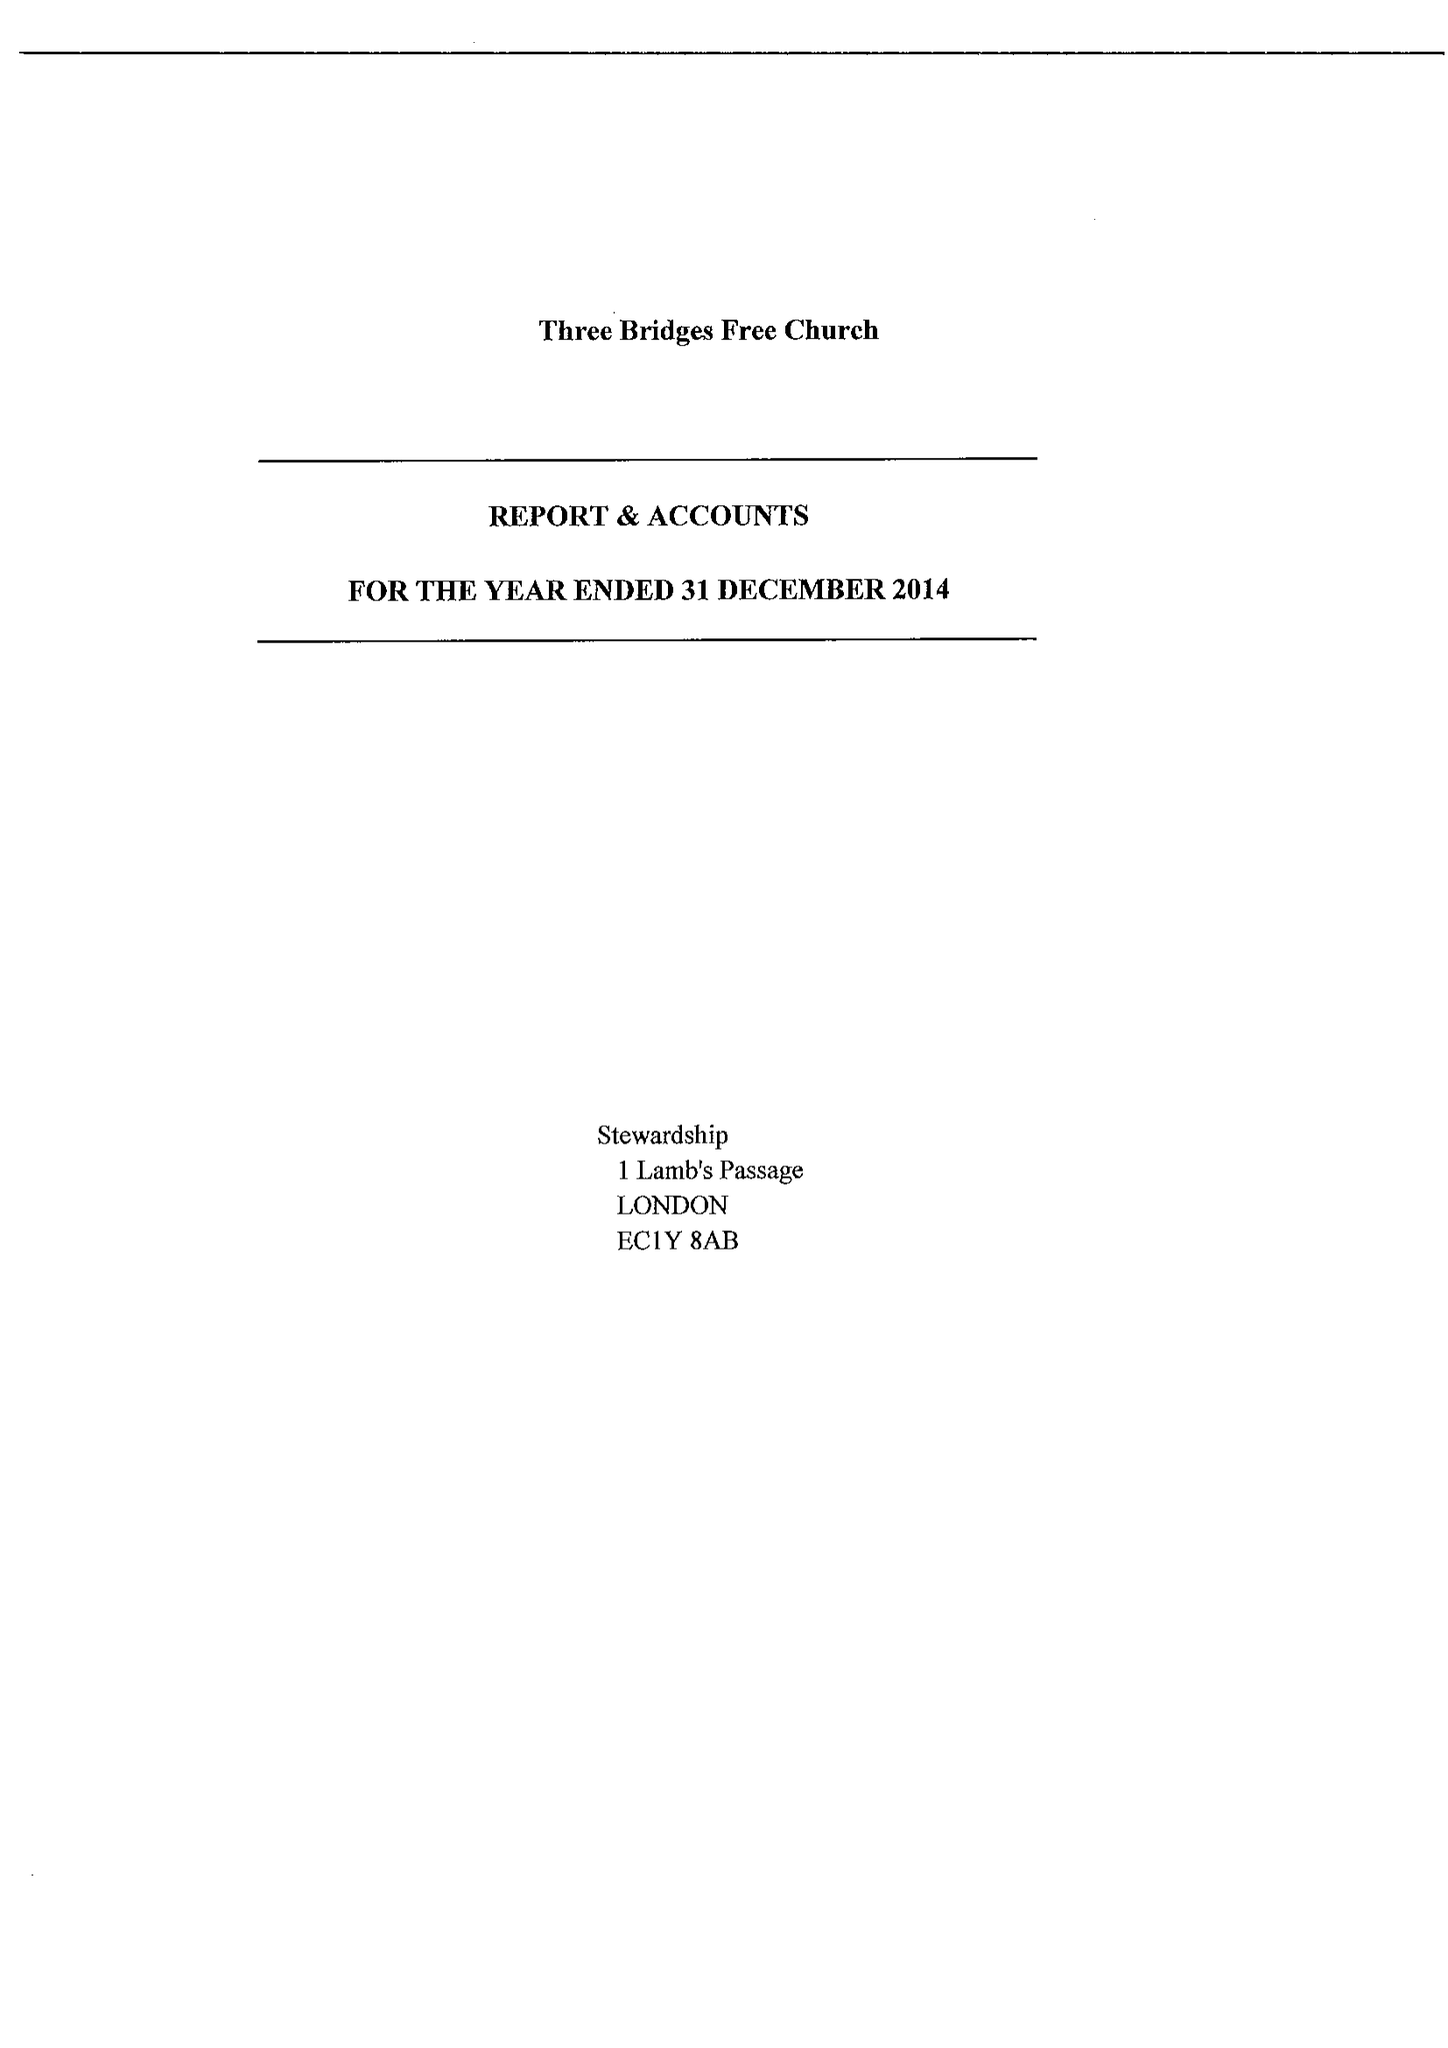What is the value for the address__post_town?
Answer the question using a single word or phrase. CRAWLEY 